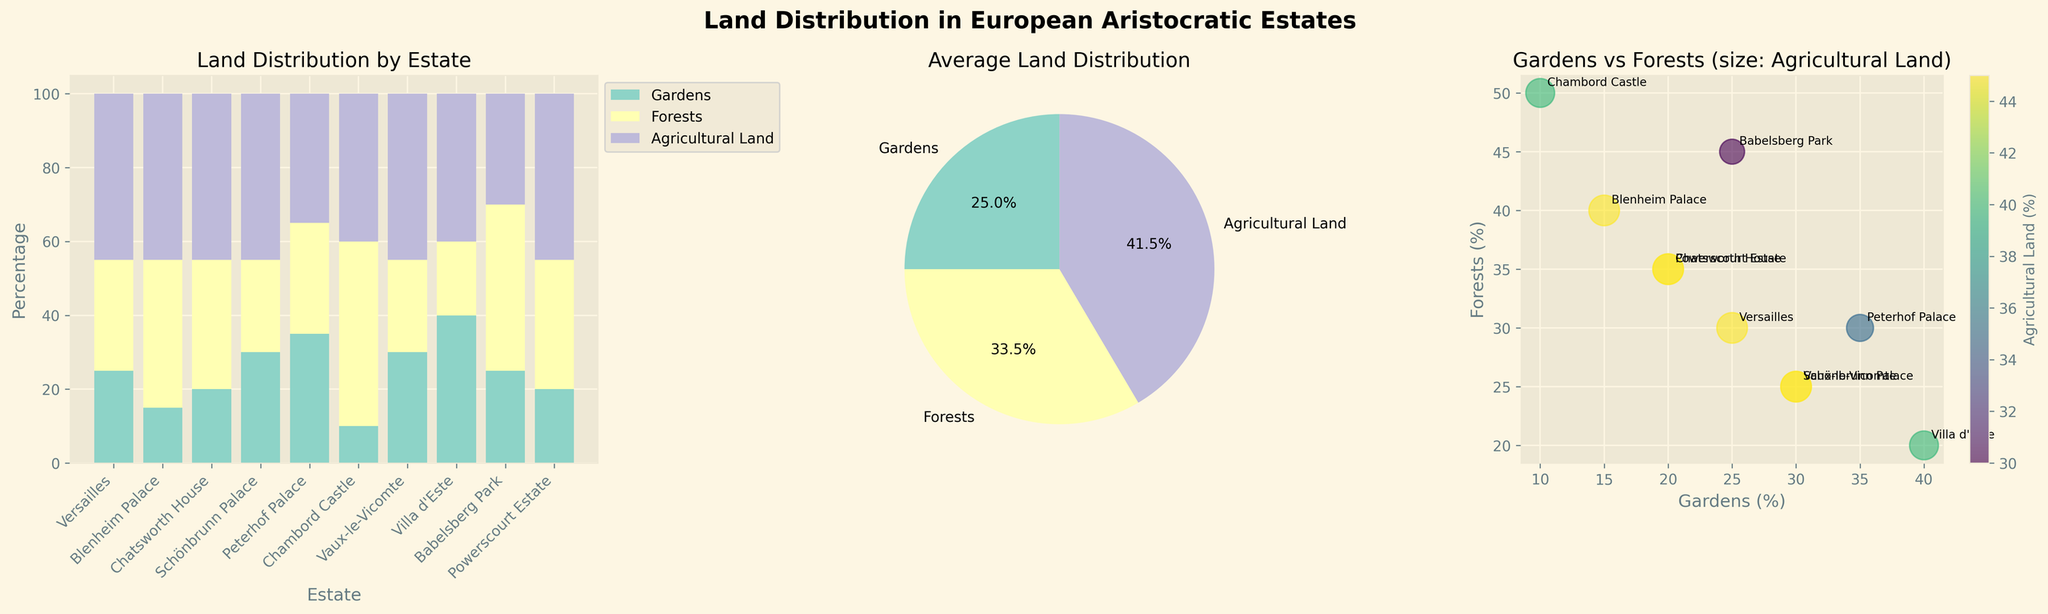What is the title of the figure? The title of the figure is typically placed at the top and is often in bold or larger font size. Here, the title "Land Distribution in European Aristocratic Estates" is prominently displayed at the top of the figure.
Answer: Land Distribution in European Aristocratic Estates Which estate has the highest percentage of gardens? By examining the heights of the bars in the first subplot (stacked bar chart), the estate with the tallest bar for gardens is identified. Villa d'Este has the highest percentage of gardens at 40%.
Answer: Villa d'Este What is the average percentage of forests across all estates? The pie chart in the middle represents average land distribution. By looking at the section labeled "Forests" and its percentage, one can see it is 33.5%.
Answer: 33.5% Which estate has the least percentage of agricultural land? By comparing the bottom segments of the stacked bars (purple color), Chambord Castle shows the shortest segment for agricultural land at 40%.
Answer: Peterhof Palace How many distinct colors are used in the stacked bar chart? The stacked bar chart uses different colors for each type of land. Counting these distinct colors gives three: one for gardens (light teal), one for forests (light yellow), and one for agricultural land (light purple).
Answer: 3 What estate has the smallest total percentage of gardens, forests, and agricultural land combined? In the stacked bar chart, each stacked bar sums up to 100%, indicating all estates each have the same total percentage of land distribution.
Answer: All estates have the same total 100% Which estate shows an equal percentage of forests and agricultural land? In the stacked bar chart, Blenheim Palace can be seen to have equal heights of the forest and agricultural land segments, both being 45%.
Answer: Blenheim Palace In the scatter plot, which estate has the highest percentage of forests with a combined high percentage of agricultural land? By checking the scatter plot and noting the estate with the highest position on the forest axis and considerable size representing agricultural land, Babelsberg Park has the highest forest percentage (45%) with significant agricultural land.
Answer: Babelsberg Park Which land type occupies the largest average percentage across all estates? This can be deduced from the pie chart. By comparing the pie chart sections, agricultural land has the largest average percentage.
Answer: Agricultural land 